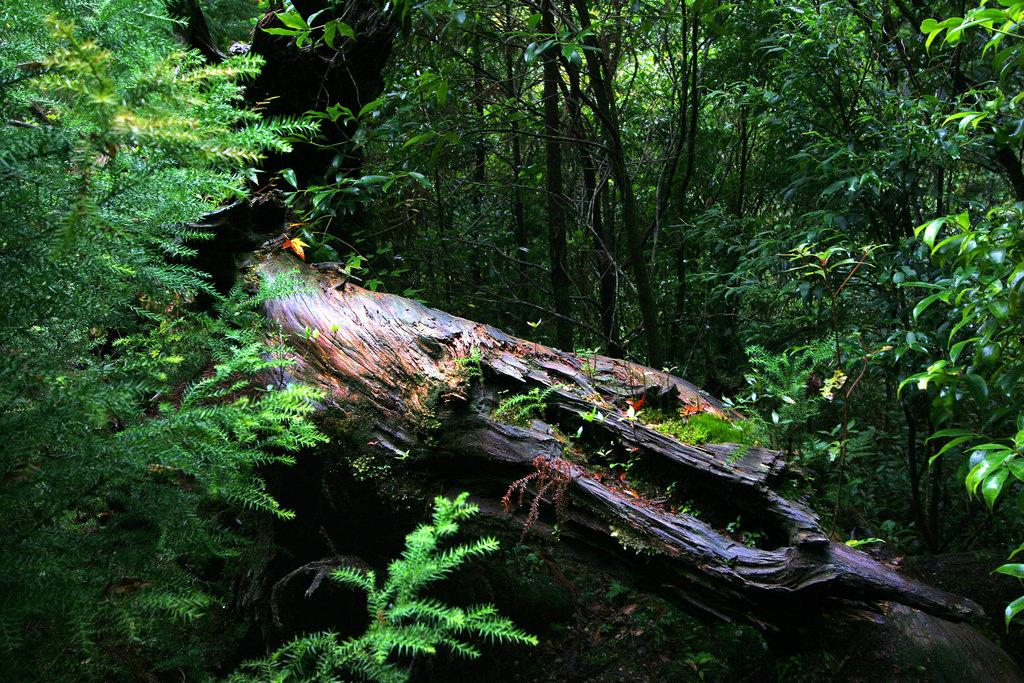What is the primary feature of the image? The primary feature of the image is the presence of many trees. Can you describe any specific object related to the trees? Yes, there is a tree log in the image. What type of country can be seen in the image? There is no country visible in the image; it only features trees and a tree log. Is there a dock present in the image? No, there is no dock present in the image. 